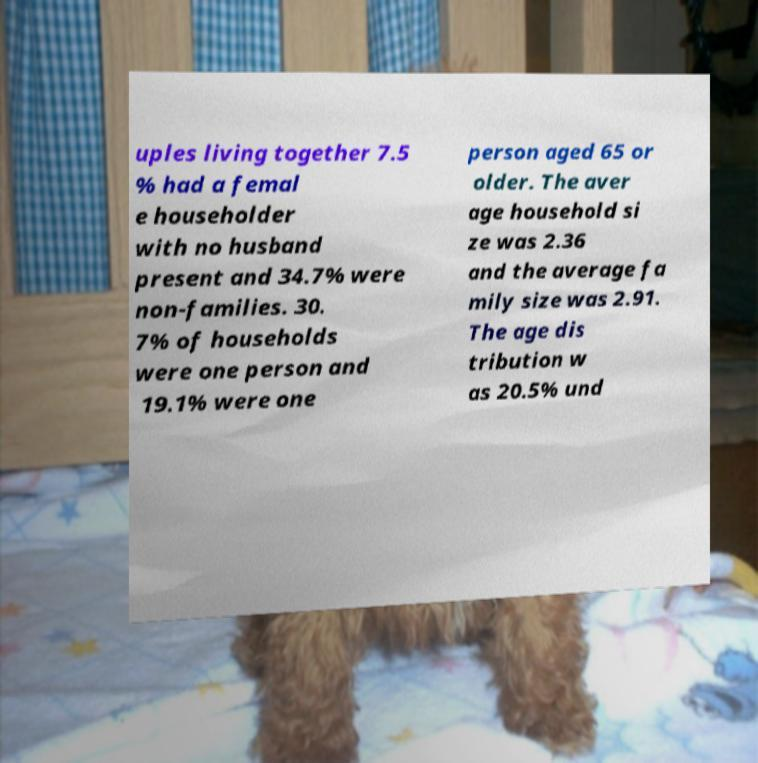I need the written content from this picture converted into text. Can you do that? uples living together 7.5 % had a femal e householder with no husband present and 34.7% were non-families. 30. 7% of households were one person and 19.1% were one person aged 65 or older. The aver age household si ze was 2.36 and the average fa mily size was 2.91. The age dis tribution w as 20.5% und 